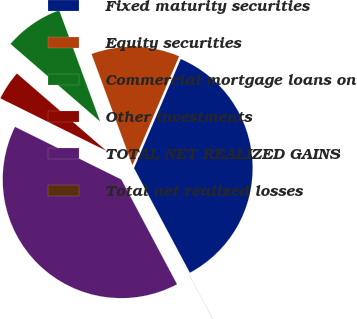Convert chart. <chart><loc_0><loc_0><loc_500><loc_500><pie_chart><fcel>Fixed maturity securities<fcel>Equity securities<fcel>Commercial mortgage loans on<fcel>Other investments<fcel>TOTAL NET REALIZED GAINS<fcel>Total net realized losses<nl><fcel>35.76%<fcel>12.05%<fcel>8.04%<fcel>4.03%<fcel>40.1%<fcel>0.02%<nl></chart> 